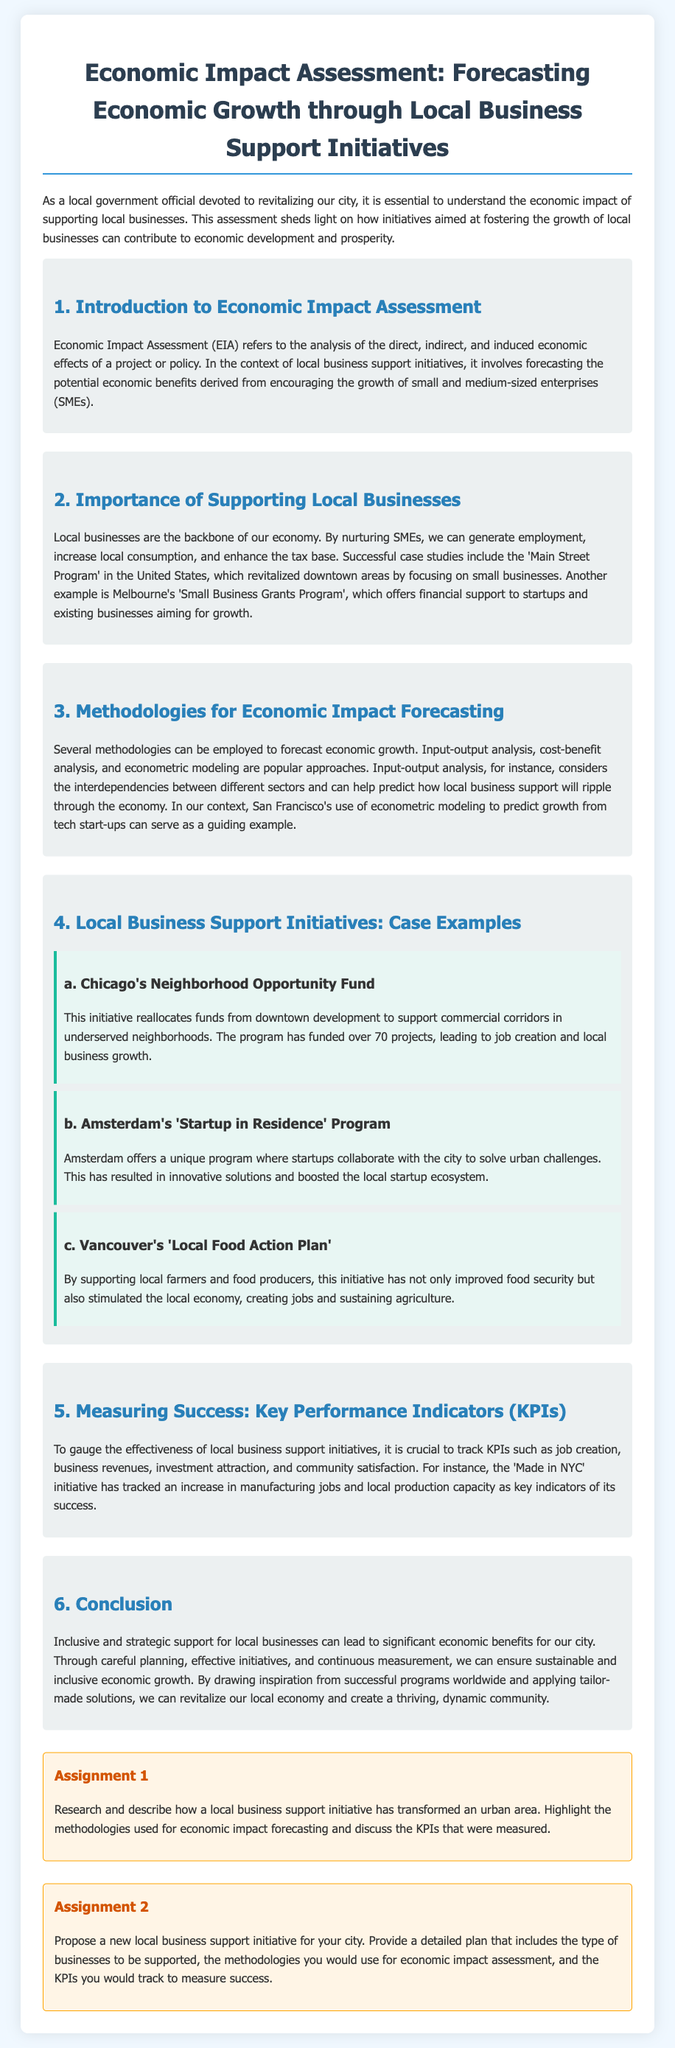what is the title of the document? The title is presented in the header of the document, summarizing the focus of the content on economic assessment and business support initiatives.
Answer: Economic Impact Assessment: Forecasting Economic Growth through Local Business Support Initiatives what is Economic Impact Assessment abbreviated as? The abbreviation is provided in the introduction section of the document as a shorthand reference to the term.
Answer: EIA which city is mentioned for using econometric modeling for growth forecasting? The document references a specific city known for employing this method to predict economic impacts from startups, highlighting its effectiveness in that context.
Answer: San Francisco what is one of the KPIs mentioned for measuring success in local business support initiatives? The document outlines various indicators that gauge the effectiveness of initiatives, with job creation being one of the key performance indicators mentioned.
Answer: job creation how many projects has Chicago's Neighborhood Opportunity Fund funded? The number of projects funded by this specific initiative is noted in the case example provided in the document.
Answer: over 70 projects what is the main goal of the 'Startup in Residence' Program in Amsterdam? The document outlines the purpose of this program focusing on collaboration with the city, which is integral to understanding its objectives.
Answer: solve urban challenges what does the 'Local Food Action Plan' aim to improve? This initiative is discussed in terms of its impact on a specific sector, highlighting its contributions to community welfare through local support.
Answer: food security what type of analysis is used to predict how local business support will ripple through the economy? The document describes a specific analytical approach that considers interdependencies between sectors, reflecting its relevance to understanding economic flows.
Answer: input-output analysis how many assignments are listed in the document? The document offers two distinct assignments designed to encourage further research and proposal development, which is explicitly stated in the assignment section.
Answer: 2 